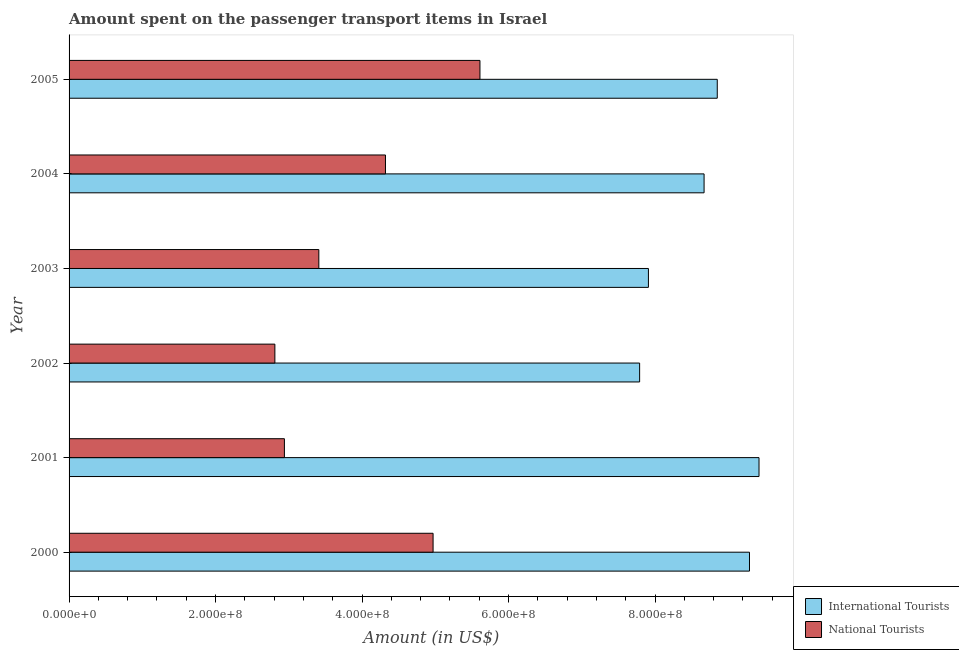How many different coloured bars are there?
Give a very brief answer. 2. How many groups of bars are there?
Provide a succinct answer. 6. Are the number of bars per tick equal to the number of legend labels?
Offer a very short reply. Yes. In how many cases, is the number of bars for a given year not equal to the number of legend labels?
Provide a short and direct response. 0. What is the amount spent on transport items of national tourists in 2005?
Keep it short and to the point. 5.61e+08. Across all years, what is the maximum amount spent on transport items of national tourists?
Provide a succinct answer. 5.61e+08. Across all years, what is the minimum amount spent on transport items of international tourists?
Provide a succinct answer. 7.79e+08. In which year was the amount spent on transport items of international tourists minimum?
Offer a very short reply. 2002. What is the total amount spent on transport items of national tourists in the graph?
Offer a very short reply. 2.41e+09. What is the difference between the amount spent on transport items of international tourists in 2004 and that in 2005?
Offer a very short reply. -1.80e+07. What is the difference between the amount spent on transport items of national tourists in 2005 and the amount spent on transport items of international tourists in 2003?
Your answer should be very brief. -2.30e+08. What is the average amount spent on transport items of national tourists per year?
Offer a very short reply. 4.01e+08. In the year 2004, what is the difference between the amount spent on transport items of international tourists and amount spent on transport items of national tourists?
Provide a short and direct response. 4.35e+08. In how many years, is the amount spent on transport items of international tourists greater than 280000000 US$?
Give a very brief answer. 6. What is the ratio of the amount spent on transport items of national tourists in 2001 to that in 2004?
Keep it short and to the point. 0.68. What is the difference between the highest and the second highest amount spent on transport items of national tourists?
Give a very brief answer. 6.40e+07. What is the difference between the highest and the lowest amount spent on transport items of international tourists?
Offer a very short reply. 1.63e+08. In how many years, is the amount spent on transport items of national tourists greater than the average amount spent on transport items of national tourists taken over all years?
Offer a terse response. 3. Is the sum of the amount spent on transport items of international tourists in 2001 and 2005 greater than the maximum amount spent on transport items of national tourists across all years?
Offer a very short reply. Yes. What does the 2nd bar from the top in 2005 represents?
Give a very brief answer. International Tourists. What does the 2nd bar from the bottom in 2001 represents?
Make the answer very short. National Tourists. Are the values on the major ticks of X-axis written in scientific E-notation?
Give a very brief answer. Yes. How many legend labels are there?
Provide a succinct answer. 2. What is the title of the graph?
Your response must be concise. Amount spent on the passenger transport items in Israel. What is the label or title of the X-axis?
Keep it short and to the point. Amount (in US$). What is the label or title of the Y-axis?
Provide a succinct answer. Year. What is the Amount (in US$) of International Tourists in 2000?
Offer a terse response. 9.29e+08. What is the Amount (in US$) in National Tourists in 2000?
Provide a succinct answer. 4.97e+08. What is the Amount (in US$) in International Tourists in 2001?
Ensure brevity in your answer.  9.42e+08. What is the Amount (in US$) in National Tourists in 2001?
Your answer should be very brief. 2.94e+08. What is the Amount (in US$) in International Tourists in 2002?
Your response must be concise. 7.79e+08. What is the Amount (in US$) of National Tourists in 2002?
Your answer should be very brief. 2.81e+08. What is the Amount (in US$) in International Tourists in 2003?
Your answer should be very brief. 7.91e+08. What is the Amount (in US$) of National Tourists in 2003?
Give a very brief answer. 3.41e+08. What is the Amount (in US$) in International Tourists in 2004?
Ensure brevity in your answer.  8.67e+08. What is the Amount (in US$) in National Tourists in 2004?
Your response must be concise. 4.32e+08. What is the Amount (in US$) of International Tourists in 2005?
Offer a very short reply. 8.85e+08. What is the Amount (in US$) of National Tourists in 2005?
Make the answer very short. 5.61e+08. Across all years, what is the maximum Amount (in US$) in International Tourists?
Ensure brevity in your answer.  9.42e+08. Across all years, what is the maximum Amount (in US$) in National Tourists?
Offer a terse response. 5.61e+08. Across all years, what is the minimum Amount (in US$) in International Tourists?
Your answer should be very brief. 7.79e+08. Across all years, what is the minimum Amount (in US$) in National Tourists?
Keep it short and to the point. 2.81e+08. What is the total Amount (in US$) in International Tourists in the graph?
Your answer should be compact. 5.19e+09. What is the total Amount (in US$) in National Tourists in the graph?
Offer a very short reply. 2.41e+09. What is the difference between the Amount (in US$) of International Tourists in 2000 and that in 2001?
Your answer should be compact. -1.30e+07. What is the difference between the Amount (in US$) of National Tourists in 2000 and that in 2001?
Provide a succinct answer. 2.03e+08. What is the difference between the Amount (in US$) of International Tourists in 2000 and that in 2002?
Your response must be concise. 1.50e+08. What is the difference between the Amount (in US$) in National Tourists in 2000 and that in 2002?
Your answer should be very brief. 2.16e+08. What is the difference between the Amount (in US$) of International Tourists in 2000 and that in 2003?
Ensure brevity in your answer.  1.38e+08. What is the difference between the Amount (in US$) of National Tourists in 2000 and that in 2003?
Provide a short and direct response. 1.56e+08. What is the difference between the Amount (in US$) in International Tourists in 2000 and that in 2004?
Make the answer very short. 6.20e+07. What is the difference between the Amount (in US$) of National Tourists in 2000 and that in 2004?
Your answer should be very brief. 6.50e+07. What is the difference between the Amount (in US$) in International Tourists in 2000 and that in 2005?
Your answer should be compact. 4.40e+07. What is the difference between the Amount (in US$) of National Tourists in 2000 and that in 2005?
Offer a terse response. -6.40e+07. What is the difference between the Amount (in US$) in International Tourists in 2001 and that in 2002?
Offer a very short reply. 1.63e+08. What is the difference between the Amount (in US$) in National Tourists in 2001 and that in 2002?
Your answer should be very brief. 1.30e+07. What is the difference between the Amount (in US$) of International Tourists in 2001 and that in 2003?
Your response must be concise. 1.51e+08. What is the difference between the Amount (in US$) of National Tourists in 2001 and that in 2003?
Provide a succinct answer. -4.70e+07. What is the difference between the Amount (in US$) of International Tourists in 2001 and that in 2004?
Provide a succinct answer. 7.50e+07. What is the difference between the Amount (in US$) in National Tourists in 2001 and that in 2004?
Your answer should be compact. -1.38e+08. What is the difference between the Amount (in US$) in International Tourists in 2001 and that in 2005?
Your response must be concise. 5.70e+07. What is the difference between the Amount (in US$) in National Tourists in 2001 and that in 2005?
Your answer should be compact. -2.67e+08. What is the difference between the Amount (in US$) of International Tourists in 2002 and that in 2003?
Make the answer very short. -1.20e+07. What is the difference between the Amount (in US$) in National Tourists in 2002 and that in 2003?
Give a very brief answer. -6.00e+07. What is the difference between the Amount (in US$) of International Tourists in 2002 and that in 2004?
Offer a terse response. -8.80e+07. What is the difference between the Amount (in US$) in National Tourists in 2002 and that in 2004?
Your answer should be very brief. -1.51e+08. What is the difference between the Amount (in US$) of International Tourists in 2002 and that in 2005?
Provide a succinct answer. -1.06e+08. What is the difference between the Amount (in US$) of National Tourists in 2002 and that in 2005?
Offer a terse response. -2.80e+08. What is the difference between the Amount (in US$) in International Tourists in 2003 and that in 2004?
Your answer should be very brief. -7.60e+07. What is the difference between the Amount (in US$) in National Tourists in 2003 and that in 2004?
Offer a terse response. -9.10e+07. What is the difference between the Amount (in US$) in International Tourists in 2003 and that in 2005?
Offer a terse response. -9.40e+07. What is the difference between the Amount (in US$) of National Tourists in 2003 and that in 2005?
Make the answer very short. -2.20e+08. What is the difference between the Amount (in US$) of International Tourists in 2004 and that in 2005?
Ensure brevity in your answer.  -1.80e+07. What is the difference between the Amount (in US$) of National Tourists in 2004 and that in 2005?
Offer a very short reply. -1.29e+08. What is the difference between the Amount (in US$) of International Tourists in 2000 and the Amount (in US$) of National Tourists in 2001?
Keep it short and to the point. 6.35e+08. What is the difference between the Amount (in US$) of International Tourists in 2000 and the Amount (in US$) of National Tourists in 2002?
Give a very brief answer. 6.48e+08. What is the difference between the Amount (in US$) in International Tourists in 2000 and the Amount (in US$) in National Tourists in 2003?
Provide a short and direct response. 5.88e+08. What is the difference between the Amount (in US$) in International Tourists in 2000 and the Amount (in US$) in National Tourists in 2004?
Make the answer very short. 4.97e+08. What is the difference between the Amount (in US$) in International Tourists in 2000 and the Amount (in US$) in National Tourists in 2005?
Offer a terse response. 3.68e+08. What is the difference between the Amount (in US$) of International Tourists in 2001 and the Amount (in US$) of National Tourists in 2002?
Offer a very short reply. 6.61e+08. What is the difference between the Amount (in US$) of International Tourists in 2001 and the Amount (in US$) of National Tourists in 2003?
Make the answer very short. 6.01e+08. What is the difference between the Amount (in US$) of International Tourists in 2001 and the Amount (in US$) of National Tourists in 2004?
Give a very brief answer. 5.10e+08. What is the difference between the Amount (in US$) of International Tourists in 2001 and the Amount (in US$) of National Tourists in 2005?
Your answer should be very brief. 3.81e+08. What is the difference between the Amount (in US$) in International Tourists in 2002 and the Amount (in US$) in National Tourists in 2003?
Make the answer very short. 4.38e+08. What is the difference between the Amount (in US$) in International Tourists in 2002 and the Amount (in US$) in National Tourists in 2004?
Provide a short and direct response. 3.47e+08. What is the difference between the Amount (in US$) in International Tourists in 2002 and the Amount (in US$) in National Tourists in 2005?
Your response must be concise. 2.18e+08. What is the difference between the Amount (in US$) of International Tourists in 2003 and the Amount (in US$) of National Tourists in 2004?
Your answer should be very brief. 3.59e+08. What is the difference between the Amount (in US$) of International Tourists in 2003 and the Amount (in US$) of National Tourists in 2005?
Provide a short and direct response. 2.30e+08. What is the difference between the Amount (in US$) of International Tourists in 2004 and the Amount (in US$) of National Tourists in 2005?
Make the answer very short. 3.06e+08. What is the average Amount (in US$) of International Tourists per year?
Keep it short and to the point. 8.66e+08. What is the average Amount (in US$) in National Tourists per year?
Your answer should be very brief. 4.01e+08. In the year 2000, what is the difference between the Amount (in US$) of International Tourists and Amount (in US$) of National Tourists?
Provide a short and direct response. 4.32e+08. In the year 2001, what is the difference between the Amount (in US$) of International Tourists and Amount (in US$) of National Tourists?
Your answer should be very brief. 6.48e+08. In the year 2002, what is the difference between the Amount (in US$) in International Tourists and Amount (in US$) in National Tourists?
Offer a very short reply. 4.98e+08. In the year 2003, what is the difference between the Amount (in US$) of International Tourists and Amount (in US$) of National Tourists?
Your answer should be very brief. 4.50e+08. In the year 2004, what is the difference between the Amount (in US$) in International Tourists and Amount (in US$) in National Tourists?
Keep it short and to the point. 4.35e+08. In the year 2005, what is the difference between the Amount (in US$) of International Tourists and Amount (in US$) of National Tourists?
Your answer should be very brief. 3.24e+08. What is the ratio of the Amount (in US$) in International Tourists in 2000 to that in 2001?
Ensure brevity in your answer.  0.99. What is the ratio of the Amount (in US$) in National Tourists in 2000 to that in 2001?
Make the answer very short. 1.69. What is the ratio of the Amount (in US$) in International Tourists in 2000 to that in 2002?
Provide a succinct answer. 1.19. What is the ratio of the Amount (in US$) of National Tourists in 2000 to that in 2002?
Your answer should be very brief. 1.77. What is the ratio of the Amount (in US$) of International Tourists in 2000 to that in 2003?
Provide a succinct answer. 1.17. What is the ratio of the Amount (in US$) of National Tourists in 2000 to that in 2003?
Ensure brevity in your answer.  1.46. What is the ratio of the Amount (in US$) in International Tourists in 2000 to that in 2004?
Make the answer very short. 1.07. What is the ratio of the Amount (in US$) of National Tourists in 2000 to that in 2004?
Make the answer very short. 1.15. What is the ratio of the Amount (in US$) of International Tourists in 2000 to that in 2005?
Give a very brief answer. 1.05. What is the ratio of the Amount (in US$) of National Tourists in 2000 to that in 2005?
Offer a very short reply. 0.89. What is the ratio of the Amount (in US$) of International Tourists in 2001 to that in 2002?
Your answer should be very brief. 1.21. What is the ratio of the Amount (in US$) of National Tourists in 2001 to that in 2002?
Keep it short and to the point. 1.05. What is the ratio of the Amount (in US$) in International Tourists in 2001 to that in 2003?
Keep it short and to the point. 1.19. What is the ratio of the Amount (in US$) in National Tourists in 2001 to that in 2003?
Ensure brevity in your answer.  0.86. What is the ratio of the Amount (in US$) in International Tourists in 2001 to that in 2004?
Provide a short and direct response. 1.09. What is the ratio of the Amount (in US$) in National Tourists in 2001 to that in 2004?
Make the answer very short. 0.68. What is the ratio of the Amount (in US$) of International Tourists in 2001 to that in 2005?
Offer a terse response. 1.06. What is the ratio of the Amount (in US$) in National Tourists in 2001 to that in 2005?
Your answer should be very brief. 0.52. What is the ratio of the Amount (in US$) in International Tourists in 2002 to that in 2003?
Your answer should be very brief. 0.98. What is the ratio of the Amount (in US$) of National Tourists in 2002 to that in 2003?
Provide a succinct answer. 0.82. What is the ratio of the Amount (in US$) in International Tourists in 2002 to that in 2004?
Your answer should be very brief. 0.9. What is the ratio of the Amount (in US$) in National Tourists in 2002 to that in 2004?
Make the answer very short. 0.65. What is the ratio of the Amount (in US$) in International Tourists in 2002 to that in 2005?
Your answer should be very brief. 0.88. What is the ratio of the Amount (in US$) in National Tourists in 2002 to that in 2005?
Ensure brevity in your answer.  0.5. What is the ratio of the Amount (in US$) in International Tourists in 2003 to that in 2004?
Give a very brief answer. 0.91. What is the ratio of the Amount (in US$) in National Tourists in 2003 to that in 2004?
Your answer should be compact. 0.79. What is the ratio of the Amount (in US$) in International Tourists in 2003 to that in 2005?
Provide a succinct answer. 0.89. What is the ratio of the Amount (in US$) in National Tourists in 2003 to that in 2005?
Ensure brevity in your answer.  0.61. What is the ratio of the Amount (in US$) of International Tourists in 2004 to that in 2005?
Make the answer very short. 0.98. What is the ratio of the Amount (in US$) in National Tourists in 2004 to that in 2005?
Your response must be concise. 0.77. What is the difference between the highest and the second highest Amount (in US$) of International Tourists?
Provide a succinct answer. 1.30e+07. What is the difference between the highest and the second highest Amount (in US$) in National Tourists?
Your answer should be very brief. 6.40e+07. What is the difference between the highest and the lowest Amount (in US$) in International Tourists?
Give a very brief answer. 1.63e+08. What is the difference between the highest and the lowest Amount (in US$) in National Tourists?
Your answer should be compact. 2.80e+08. 